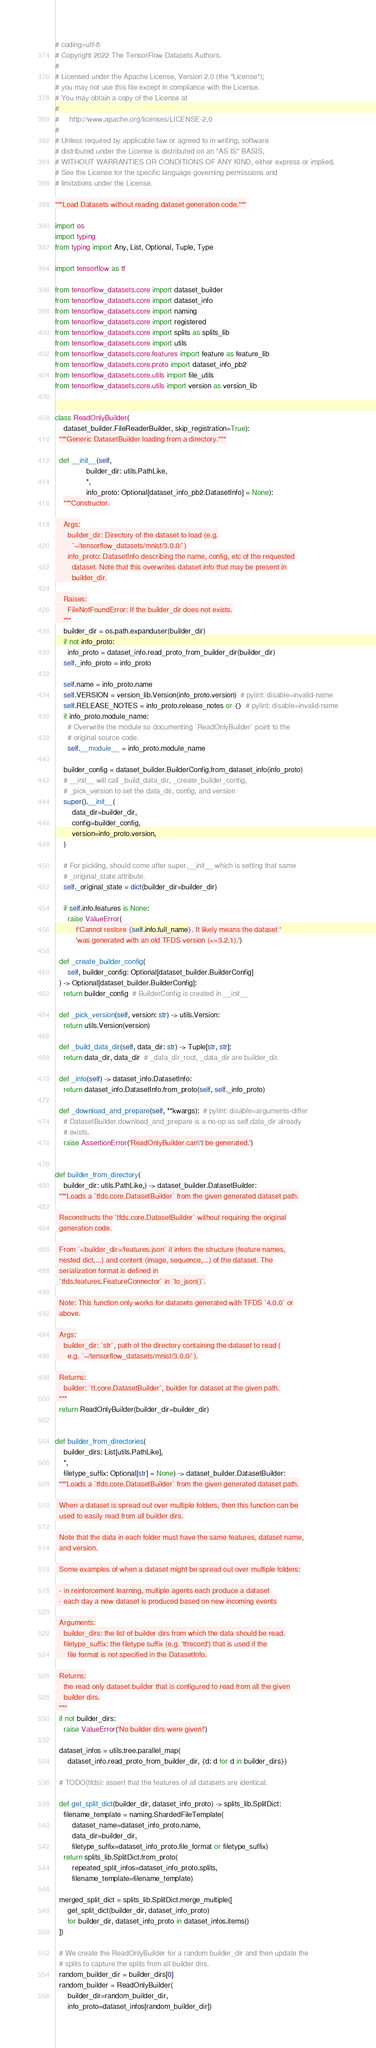Convert code to text. <code><loc_0><loc_0><loc_500><loc_500><_Python_># coding=utf-8
# Copyright 2022 The TensorFlow Datasets Authors.
#
# Licensed under the Apache License, Version 2.0 (the "License");
# you may not use this file except in compliance with the License.
# You may obtain a copy of the License at
#
#     http://www.apache.org/licenses/LICENSE-2.0
#
# Unless required by applicable law or agreed to in writing, software
# distributed under the License is distributed on an "AS IS" BASIS,
# WITHOUT WARRANTIES OR CONDITIONS OF ANY KIND, either express or implied.
# See the License for the specific language governing permissions and
# limitations under the License.

"""Load Datasets without reading dataset generation code."""

import os
import typing
from typing import Any, List, Optional, Tuple, Type

import tensorflow as tf

from tensorflow_datasets.core import dataset_builder
from tensorflow_datasets.core import dataset_info
from tensorflow_datasets.core import naming
from tensorflow_datasets.core import registered
from tensorflow_datasets.core import splits as splits_lib
from tensorflow_datasets.core import utils
from tensorflow_datasets.core.features import feature as feature_lib
from tensorflow_datasets.core.proto import dataset_info_pb2
from tensorflow_datasets.core.utils import file_utils
from tensorflow_datasets.core.utils import version as version_lib


class ReadOnlyBuilder(
    dataset_builder.FileReaderBuilder, skip_registration=True):
  """Generic DatasetBuilder loading from a directory."""

  def __init__(self,
               builder_dir: utils.PathLike,
               *,
               info_proto: Optional[dataset_info_pb2.DatasetInfo] = None):
    """Constructor.

    Args:
      builder_dir: Directory of the dataset to load (e.g.
        `~/tensorflow_datasets/mnist/3.0.0/`)
      info_proto: DatasetInfo describing the name, config, etc of the requested
        dataset. Note that this overwrites dataset info that may be present in
        builder_dir.

    Raises:
      FileNotFoundError: If the builder_dir does not exists.
    """
    builder_dir = os.path.expanduser(builder_dir)
    if not info_proto:
      info_proto = dataset_info.read_proto_from_builder_dir(builder_dir)
    self._info_proto = info_proto

    self.name = info_proto.name
    self.VERSION = version_lib.Version(info_proto.version)  # pylint: disable=invalid-name
    self.RELEASE_NOTES = info_proto.release_notes or {}  # pylint: disable=invalid-name
    if info_proto.module_name:
      # Overwrite the module so documenting `ReadOnlyBuilder` point to the
      # original source code.
      self.__module__ = info_proto.module_name

    builder_config = dataset_builder.BuilderConfig.from_dataset_info(info_proto)
    # __init__ will call _build_data_dir, _create_builder_config,
    # _pick_version to set the data_dir, config, and version
    super().__init__(
        data_dir=builder_dir,
        config=builder_config,
        version=info_proto.version,
    )

    # For pickling, should come after super.__init__ which is setting that same
    # _original_state attribute.
    self._original_state = dict(builder_dir=builder_dir)

    if self.info.features is None:
      raise ValueError(
          f'Cannot restore {self.info.full_name}. It likely means the dataset '
          'was generated with an old TFDS version (<=3.2.1).')

  def _create_builder_config(
      self, builder_config: Optional[dataset_builder.BuilderConfig]
  ) -> Optional[dataset_builder.BuilderConfig]:
    return builder_config  # BuilderConfig is created in __init__

  def _pick_version(self, version: str) -> utils.Version:
    return utils.Version(version)

  def _build_data_dir(self, data_dir: str) -> Tuple[str, str]:
    return data_dir, data_dir  # _data_dir_root, _data_dir are builder_dir.

  def _info(self) -> dataset_info.DatasetInfo:
    return dataset_info.DatasetInfo.from_proto(self, self._info_proto)

  def _download_and_prepare(self, **kwargs):  # pylint: disable=arguments-differ
    # DatasetBuilder.download_and_prepare is a no-op as self.data_dir already
    # exists.
    raise AssertionError('ReadOnlyBuilder can\'t be generated.')


def builder_from_directory(
    builder_dir: utils.PathLike,) -> dataset_builder.DatasetBuilder:
  """Loads a `tfds.core.DatasetBuilder` from the given generated dataset path.

  Reconstructs the `tfds.core.DatasetBuilder` without requiring the original
  generation code.

  From `<builder_dir>/features.json` it infers the structure (feature names,
  nested dict,...) and content (image, sequence,...) of the dataset. The
  serialization format is defined in
  `tfds.features.FeatureConnector` in `to_json()`.

  Note: This function only works for datasets generated with TFDS `4.0.0` or
  above.

  Args:
    builder_dir: `str`, path of the directory containing the dataset to read (
      e.g. `~/tensorflow_datasets/mnist/3.0.0/`).

  Returns:
    builder: `tf.core.DatasetBuilder`, builder for dataset at the given path.
  """
  return ReadOnlyBuilder(builder_dir=builder_dir)


def builder_from_directories(
    builder_dirs: List[utils.PathLike],
    *,
    filetype_suffix: Optional[str] = None) -> dataset_builder.DatasetBuilder:
  """Loads a `tfds.core.DatasetBuilder` from the given generated dataset path.

  When a dataset is spread out over multiple folders, then this function can be
  used to easily read from all builder dirs.

  Note that the data in each folder must have the same features, dataset name,
  and version.

  Some examples of when a dataset might be spread out over multiple folders:

  - in reinforcement learning, multiple agents each produce a dataset
  - each day a new dataset is produced based on new incoming events

  Arguments:
    builder_dirs: the list of builder dirs from which the data should be read.
    filetype_suffix: the filetype suffix (e.g. 'tfrecord') that is used if the
      file format is not specified in the DatasetInfo.

  Returns:
    the read only dataset builder that is configured to read from all the given
    builder dirs.
  """
  if not builder_dirs:
    raise ValueError('No builder dirs were given!')

  dataset_infos = utils.tree.parallel_map(
      dataset_info.read_proto_from_builder_dir, {d: d for d in builder_dirs})

  # TODO(tfds): assert that the features of all datasets are identical.

  def get_split_dict(builder_dir, dataset_info_proto) -> splits_lib.SplitDict:
    filename_template = naming.ShardedFileTemplate(
        dataset_name=dataset_info_proto.name,
        data_dir=builder_dir,
        filetype_suffix=dataset_info_proto.file_format or filetype_suffix)
    return splits_lib.SplitDict.from_proto(
        repeated_split_infos=dataset_info_proto.splits,
        filename_template=filename_template)

  merged_split_dict = splits_lib.SplitDict.merge_multiple([
      get_split_dict(builder_dir, dataset_info_proto)
      for builder_dir, dataset_info_proto in dataset_infos.items()
  ])

  # We create the ReadOnlyBuilder for a random builder_dir and then update the
  # splits to capture the splits from all builder dirs.
  random_builder_dir = builder_dirs[0]
  random_builder = ReadOnlyBuilder(
      builder_dir=random_builder_dir,
      info_proto=dataset_infos[random_builder_dir])</code> 